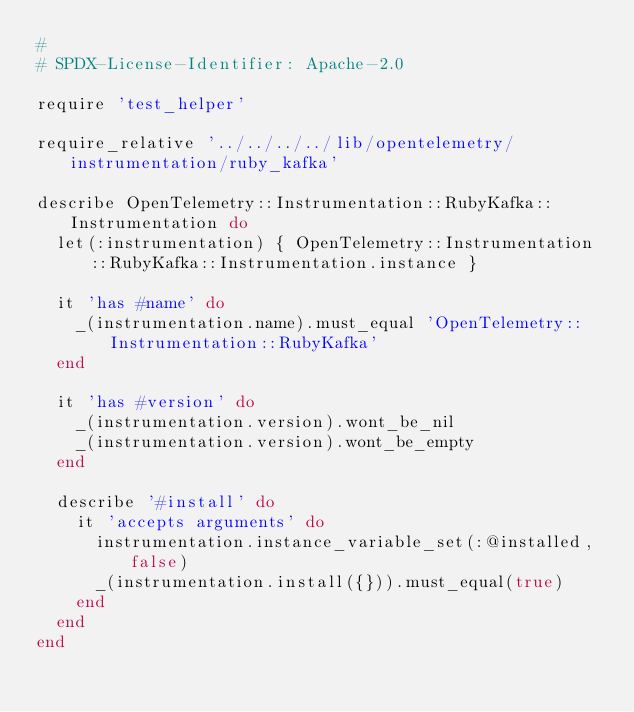<code> <loc_0><loc_0><loc_500><loc_500><_Ruby_>#
# SPDX-License-Identifier: Apache-2.0

require 'test_helper'

require_relative '../../../../lib/opentelemetry/instrumentation/ruby_kafka'

describe OpenTelemetry::Instrumentation::RubyKafka::Instrumentation do
  let(:instrumentation) { OpenTelemetry::Instrumentation::RubyKafka::Instrumentation.instance }

  it 'has #name' do
    _(instrumentation.name).must_equal 'OpenTelemetry::Instrumentation::RubyKafka'
  end

  it 'has #version' do
    _(instrumentation.version).wont_be_nil
    _(instrumentation.version).wont_be_empty
  end

  describe '#install' do
    it 'accepts arguments' do
      instrumentation.instance_variable_set(:@installed, false)
      _(instrumentation.install({})).must_equal(true)
    end
  end
end
</code> 